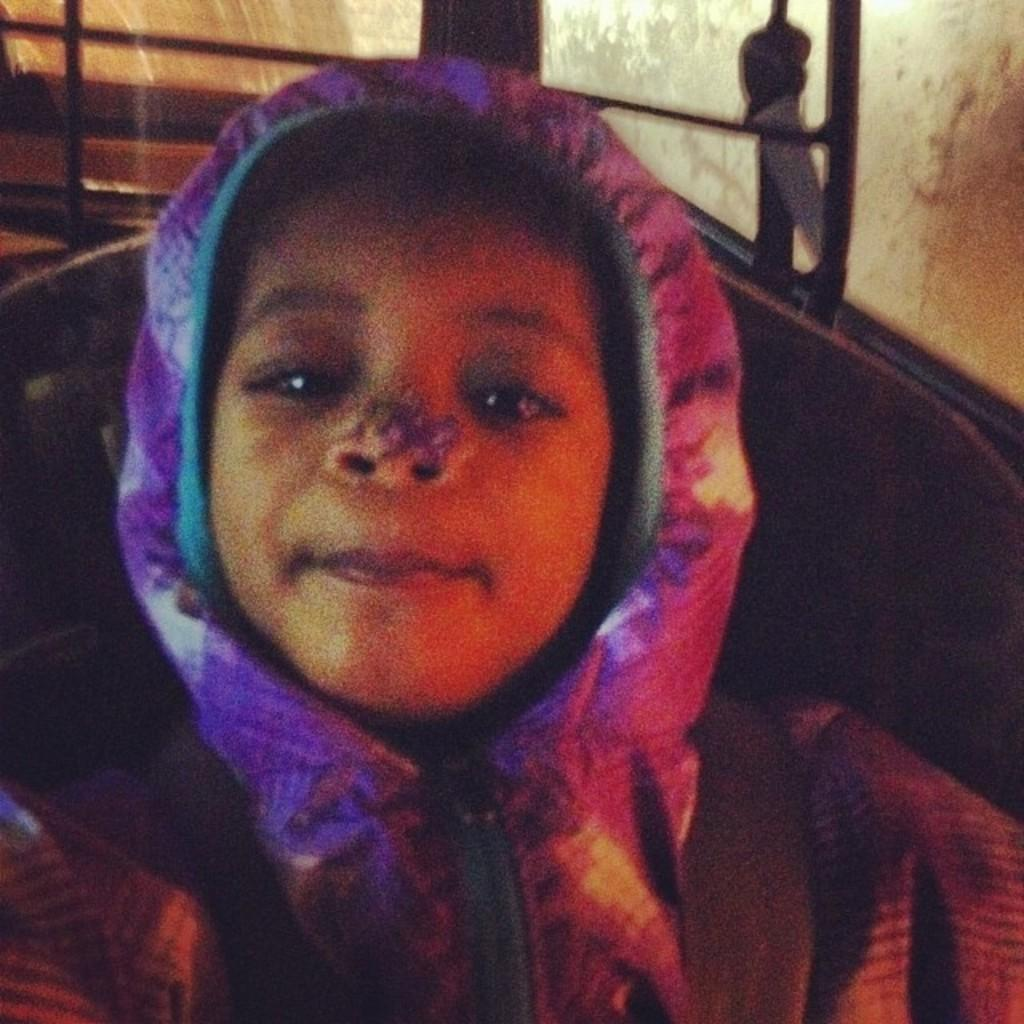What is the person in the image doing? The person is sitting on a chair in the image. Can you describe the background of the image? There are stairs attached to a wall in the background of the image. What type of wheel can be seen in the image? There is no wheel present in the image. Is there a hydrant visible in the image? There is no hydrant present in the image. 